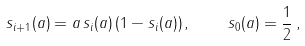Convert formula to latex. <formula><loc_0><loc_0><loc_500><loc_500>s _ { i + 1 } ( a ) = a \, s _ { i } ( a ) \left ( 1 - s _ { i } ( a ) \right ) , \quad s _ { 0 } ( a ) = \frac { 1 } { 2 } \, ,</formula> 